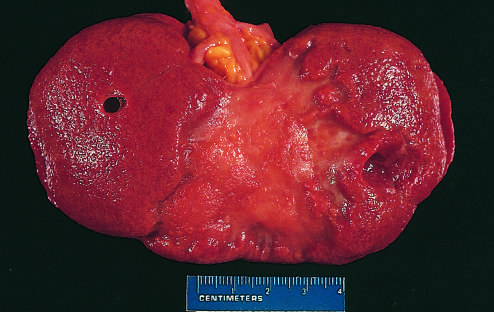s the remote kidney infarct replaced by a large fibrotic scar?
Answer the question using a single word or phrase. Yes 